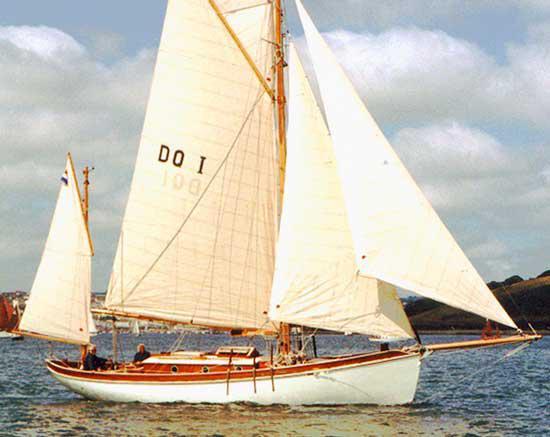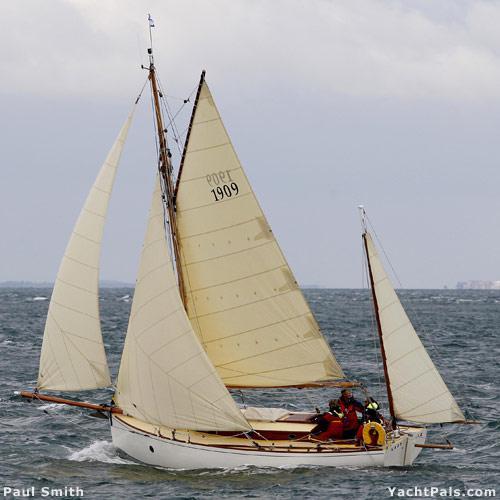The first image is the image on the left, the second image is the image on the right. Assess this claim about the two images: "All sailboats have at least four sails.". Correct or not? Answer yes or no. Yes. The first image is the image on the left, the second image is the image on the right. Considering the images on both sides, is "The boat on the right has more than three visible sails unfurled." valid? Answer yes or no. Yes. 